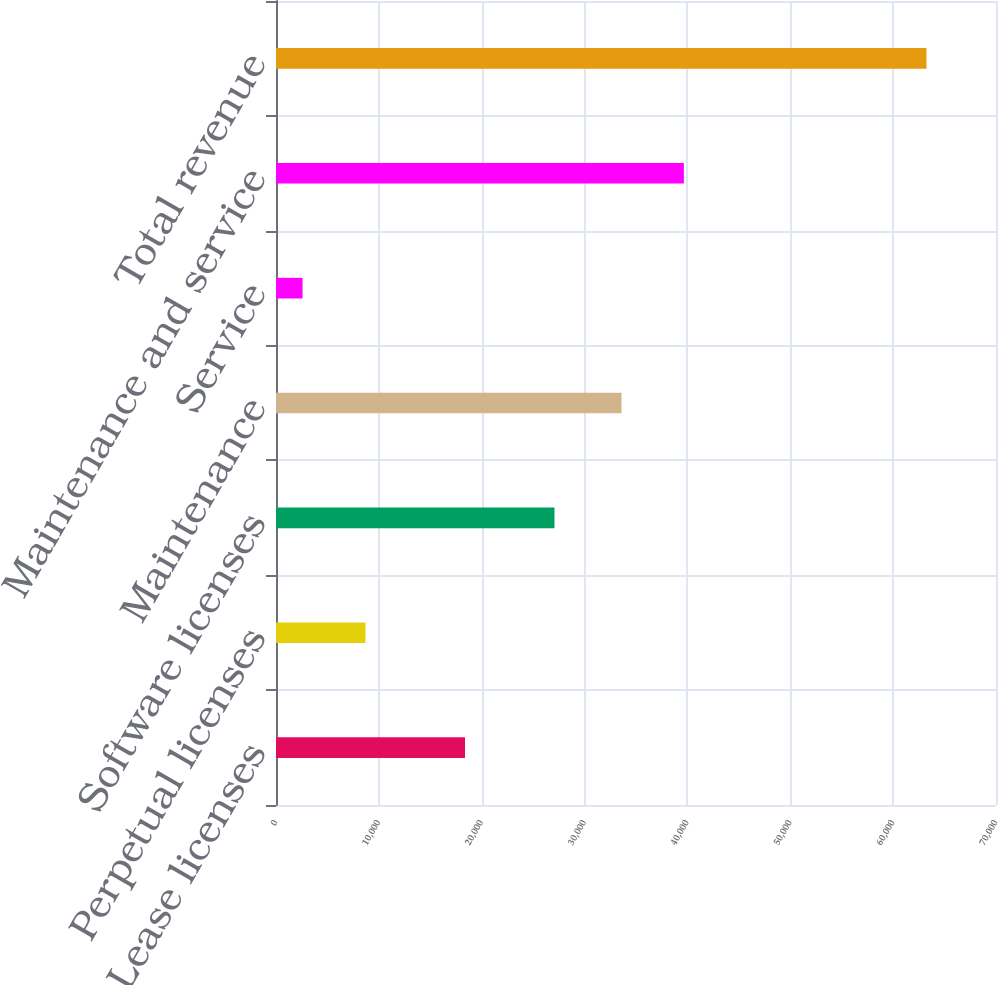Convert chart. <chart><loc_0><loc_0><loc_500><loc_500><bar_chart><fcel>Lease licenses<fcel>Perpetual licenses<fcel>Software licenses<fcel>Maintenance<fcel>Service<fcel>Maintenance and service<fcel>Total revenue<nl><fcel>18375<fcel>8699<fcel>27074<fcel>33587<fcel>2581<fcel>39653.1<fcel>63242<nl></chart> 